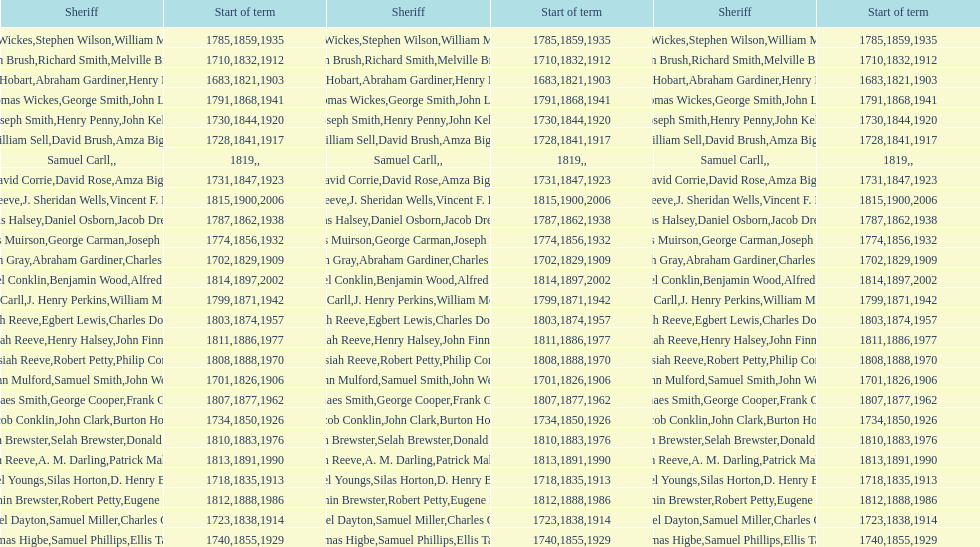What is the number of sheriff's with the last name smith? 5. 